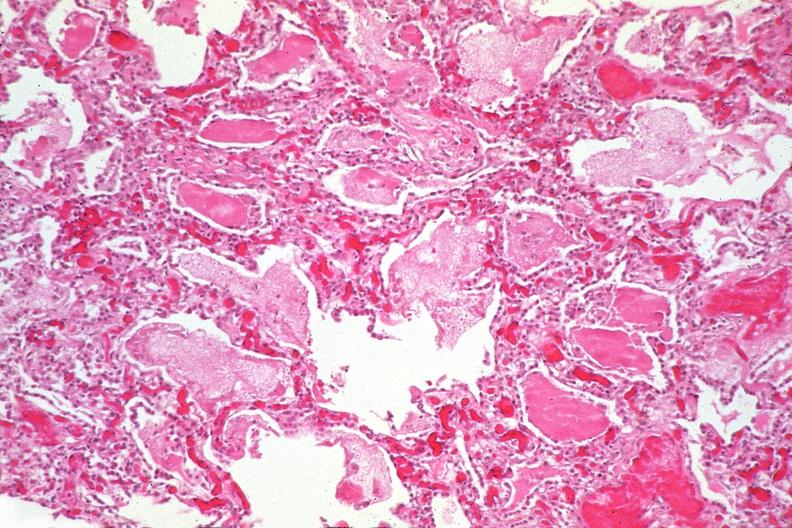s chest and abdomen slide present?
Answer the question using a single word or phrase. No 